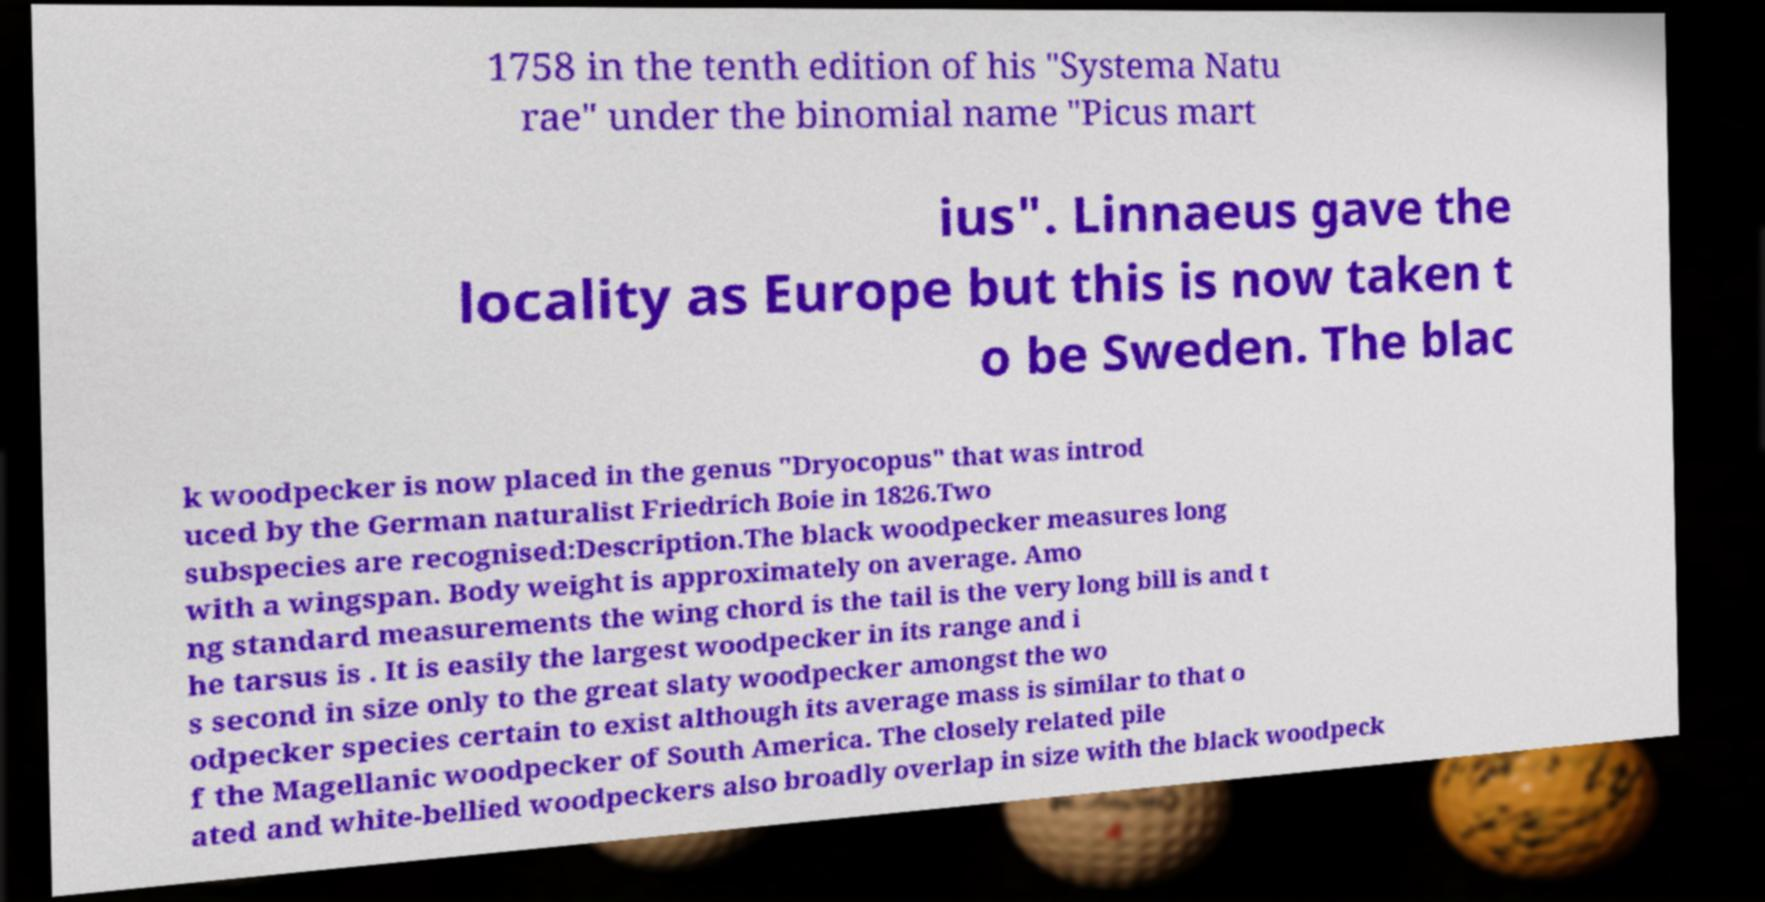What messages or text are displayed in this image? I need them in a readable, typed format. 1758 in the tenth edition of his "Systema Natu rae" under the binomial name "Picus mart ius". Linnaeus gave the locality as Europe but this is now taken t o be Sweden. The blac k woodpecker is now placed in the genus "Dryocopus" that was introd uced by the German naturalist Friedrich Boie in 1826.Two subspecies are recognised:Description.The black woodpecker measures long with a wingspan. Body weight is approximately on average. Amo ng standard measurements the wing chord is the tail is the very long bill is and t he tarsus is . It is easily the largest woodpecker in its range and i s second in size only to the great slaty woodpecker amongst the wo odpecker species certain to exist although its average mass is similar to that o f the Magellanic woodpecker of South America. The closely related pile ated and white-bellied woodpeckers also broadly overlap in size with the black woodpeck 